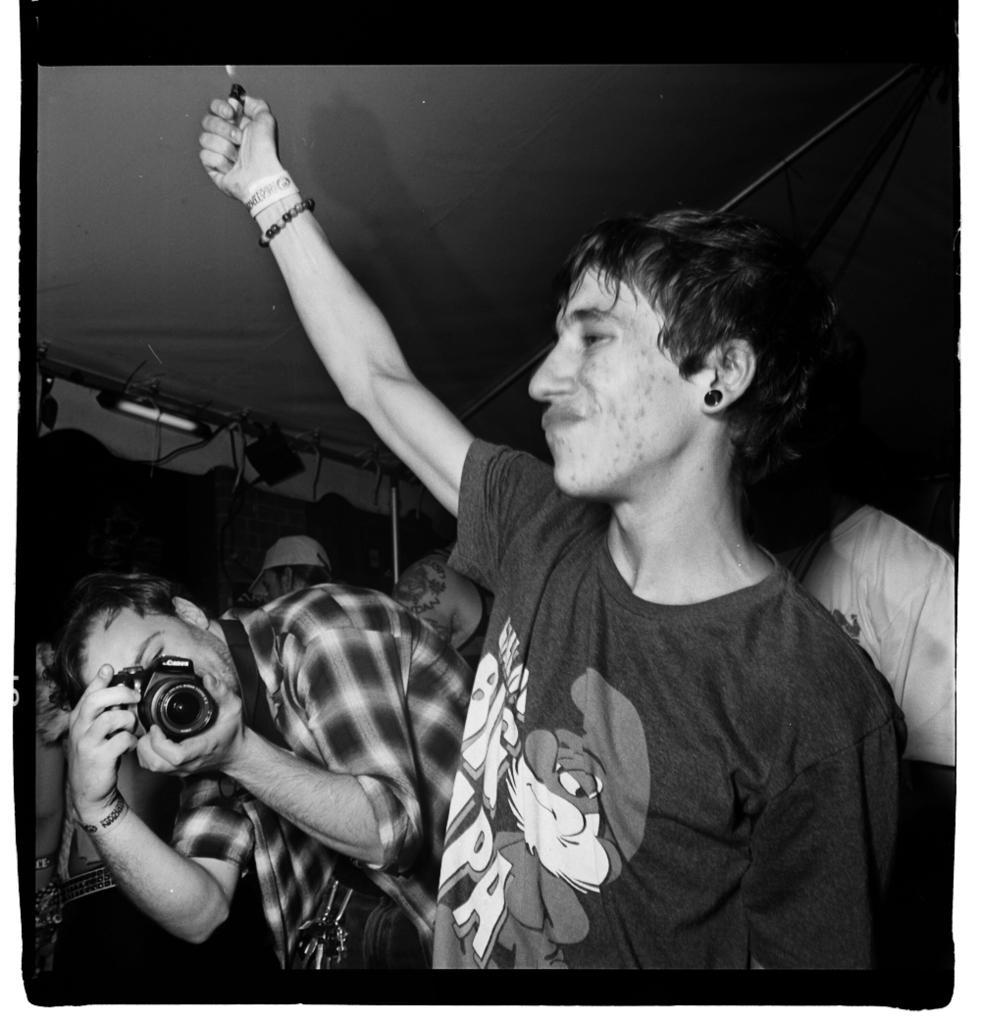Can you describe this image briefly? In the center of the image there is a boy standing and holding a lighter in his hand beside him there is another man who is holding camera in his hand he is wearing a bag. In the background there are many people standing. At the top there is a tent. 